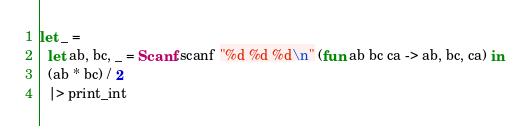<code> <loc_0><loc_0><loc_500><loc_500><_OCaml_>let _ =
  let ab, bc, _ = Scanf.scanf "%d %d %d\n" (fun ab bc ca -> ab, bc, ca) in
  (ab * bc) / 2
  |> print_int</code> 